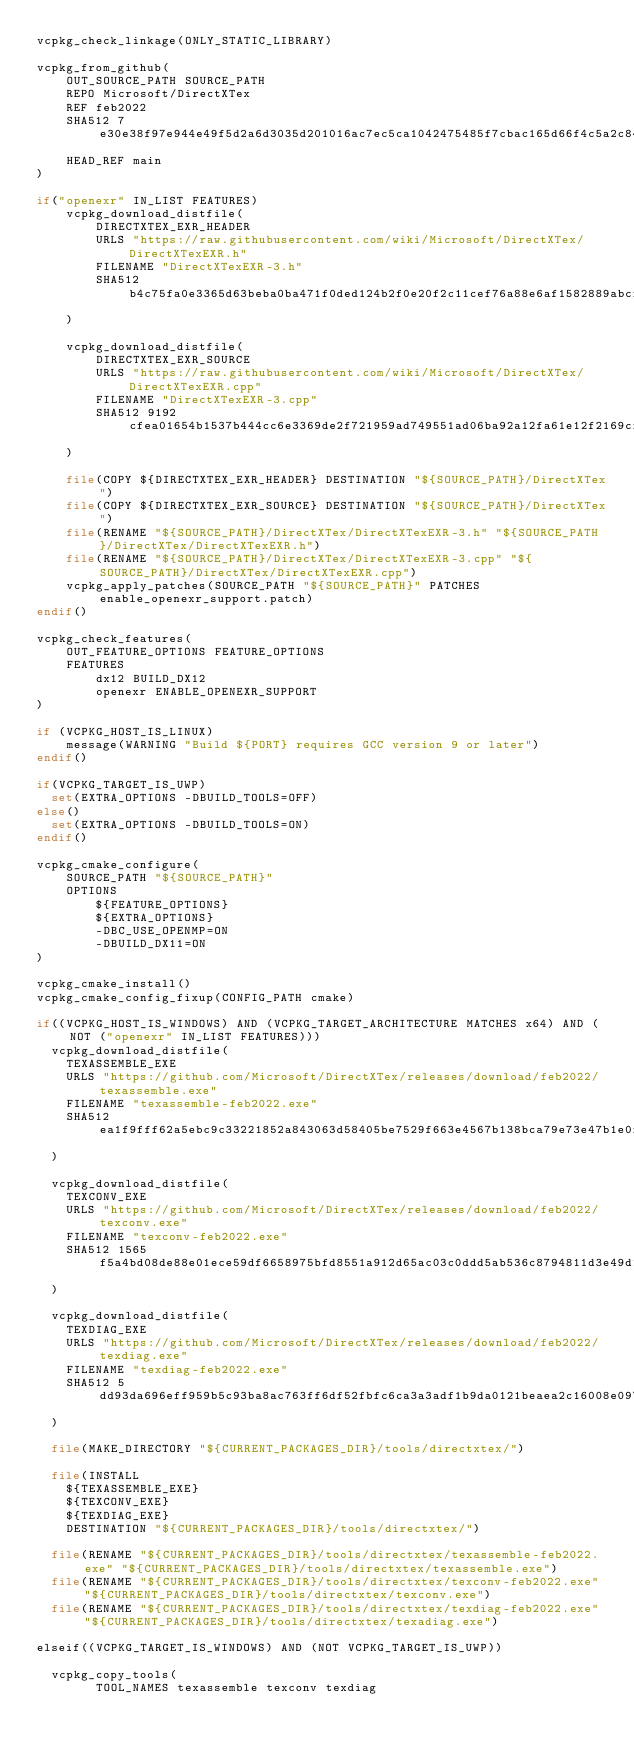Convert code to text. <code><loc_0><loc_0><loc_500><loc_500><_CMake_>vcpkg_check_linkage(ONLY_STATIC_LIBRARY)

vcpkg_from_github(
    OUT_SOURCE_PATH SOURCE_PATH
    REPO Microsoft/DirectXTex
    REF feb2022
    SHA512 7e30e38f97e944e49f5d2a6d3035d201016ac7ec5ca1042475485f7cbac165d66f4c5a2c84f2a47dad755c59b3f8947e1251b00b3e577fbc3e58f1957d8a224e
    HEAD_REF main
)

if("openexr" IN_LIST FEATURES)
    vcpkg_download_distfile(
        DIRECTXTEX_EXR_HEADER
        URLS "https://raw.githubusercontent.com/wiki/Microsoft/DirectXTex/DirectXTexEXR.h"
        FILENAME "DirectXTexEXR-3.h"
        SHA512 b4c75fa0e3365d63beba0ba471f0ded124b2f0e20f2c11cef76a88e6af1582889abcf5aa2ec74270d7b9bde7f7b4bc36fd17f030357b4139d8c83c35060344be
    )

    vcpkg_download_distfile(
        DIRECTXTEX_EXR_SOURCE
        URLS "https://raw.githubusercontent.com/wiki/Microsoft/DirectXTex/DirectXTexEXR.cpp"
        FILENAME "DirectXTexEXR-3.cpp"
        SHA512 9192cfea01654b1537b444cc6e3369de2f721959ad749551ad06ba92a12fa61e12f2169cf412788b0156220bb8bacf531160f924a4744e43e875163463586620
    )

    file(COPY ${DIRECTXTEX_EXR_HEADER} DESTINATION "${SOURCE_PATH}/DirectXTex")
    file(COPY ${DIRECTXTEX_EXR_SOURCE} DESTINATION "${SOURCE_PATH}/DirectXTex")
    file(RENAME "${SOURCE_PATH}/DirectXTex/DirectXTexEXR-3.h" "${SOURCE_PATH}/DirectXTex/DirectXTexEXR.h")
    file(RENAME "${SOURCE_PATH}/DirectXTex/DirectXTexEXR-3.cpp" "${SOURCE_PATH}/DirectXTex/DirectXTexEXR.cpp")
    vcpkg_apply_patches(SOURCE_PATH "${SOURCE_PATH}" PATCHES enable_openexr_support.patch)
endif()

vcpkg_check_features(
    OUT_FEATURE_OPTIONS FEATURE_OPTIONS
    FEATURES
        dx12 BUILD_DX12
        openexr ENABLE_OPENEXR_SUPPORT
)

if (VCPKG_HOST_IS_LINUX)
    message(WARNING "Build ${PORT} requires GCC version 9 or later")
endif()

if(VCPKG_TARGET_IS_UWP)
  set(EXTRA_OPTIONS -DBUILD_TOOLS=OFF)
else()
  set(EXTRA_OPTIONS -DBUILD_TOOLS=ON)
endif()

vcpkg_cmake_configure(
    SOURCE_PATH "${SOURCE_PATH}"
    OPTIONS
        ${FEATURE_OPTIONS}
        ${EXTRA_OPTIONS}
        -DBC_USE_OPENMP=ON
        -DBUILD_DX11=ON
)

vcpkg_cmake_install()
vcpkg_cmake_config_fixup(CONFIG_PATH cmake)

if((VCPKG_HOST_IS_WINDOWS) AND (VCPKG_TARGET_ARCHITECTURE MATCHES x64) AND (NOT ("openexr" IN_LIST FEATURES)))
  vcpkg_download_distfile(
    TEXASSEMBLE_EXE
    URLS "https://github.com/Microsoft/DirectXTex/releases/download/feb2022/texassemble.exe"
    FILENAME "texassemble-feb2022.exe"
    SHA512 ea1f9fff62a5ebc9c33221852a843063d58405be7529f663e4567b138bca79e73e47b1e0fb6054c4e024a630323c72aba505eee35414cf14970c331afa9ff43f
  )

  vcpkg_download_distfile(
    TEXCONV_EXE
    URLS "https://github.com/Microsoft/DirectXTex/releases/download/feb2022/texconv.exe"
    FILENAME "texconv-feb2022.exe"
    SHA512 1565f5a4bd08de88e01ece59df6658975bfd8551a912d65ac03c0ddd5ab536c8794811d3e49d14e8fe4c61fa2a6c9d50994d372f5d3efab7d9aeb6f3f92d56c9
  )

  vcpkg_download_distfile(
    TEXDIAG_EXE
    URLS "https://github.com/Microsoft/DirectXTex/releases/download/feb2022/texdiag.exe"
    FILENAME "texdiag-feb2022.exe"
    SHA512 5dd93da696eff959b5c93ba8ac763ff6df52fbfc6ca3a3adf1b9da0121beaea2c16008e097f74d562b7a69ed20ada50fd5d35d47311338e6c819e3483bc54ee3
  )

  file(MAKE_DIRECTORY "${CURRENT_PACKAGES_DIR}/tools/directxtex/")

  file(INSTALL
    ${TEXASSEMBLE_EXE}
    ${TEXCONV_EXE}
    ${TEXDIAG_EXE}
    DESTINATION "${CURRENT_PACKAGES_DIR}/tools/directxtex/")

  file(RENAME "${CURRENT_PACKAGES_DIR}/tools/directxtex/texassemble-feb2022.exe" "${CURRENT_PACKAGES_DIR}/tools/directxtex/texassemble.exe")
  file(RENAME "${CURRENT_PACKAGES_DIR}/tools/directxtex/texconv-feb2022.exe" "${CURRENT_PACKAGES_DIR}/tools/directxtex/texconv.exe")
  file(RENAME "${CURRENT_PACKAGES_DIR}/tools/directxtex/texdiag-feb2022.exe" "${CURRENT_PACKAGES_DIR}/tools/directxtex/texadiag.exe")

elseif((VCPKG_TARGET_IS_WINDOWS) AND (NOT VCPKG_TARGET_IS_UWP))

  vcpkg_copy_tools(
        TOOL_NAMES texassemble texconv texdiag</code> 